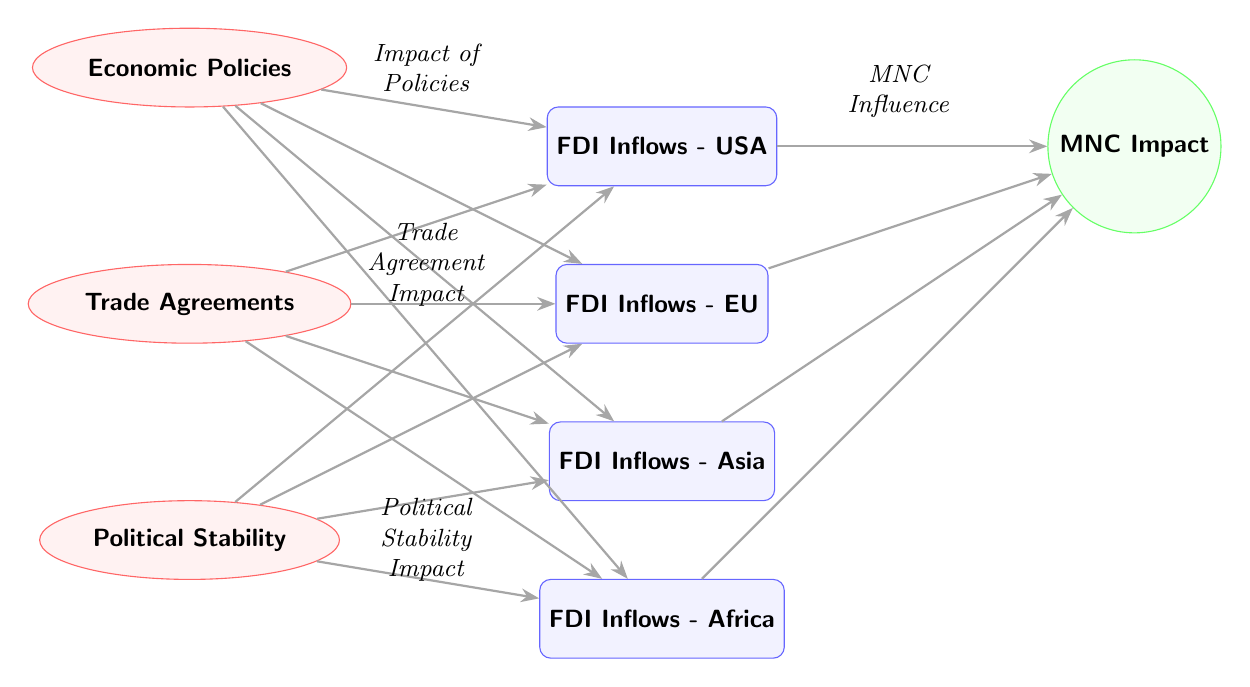What are the regions represented in the FDI inflows nodes? The diagram shows four FDI inflow nodes labeled as USA, EU, Asia, and Africa. These represent the different regions where FDI inflows are analyzed.
Answer: USA, EU, Asia, Africa How many factors influence FDI inflows according to the diagram? There are three factors depicted that influence FDI inflows: Economic Policies, Trade Agreements, and Political Stability. This can be determined by counting the factor nodes connected to the FDI inflow nodes.
Answer: 3 Which factor directly impacts the FDI inflows in Africa? Political Stability is the factor that directly impacts the FDI inflows in Africa as indicated by the arrow pointing from the Stability node to the Africa FDI inflow node.
Answer: Political Stability What is the relationship between MNC Impact and the FDI inflows? The diagram illustrates that MNC Impact is influenced by all four regions' FDI inflows (USA, EU, Asia, Africa) as indicated by the arrows pointing from each regional inflow node to the MNC Impact node.
Answer: MNC Impact is influenced by FDI inflows Which region has the most factors influencing its FDI inflows? All regions (USA, EU, Asia, Africa) have the same number of influencing factors (three: Economic Policies, Trade Agreements, Political Stability), hence no single region stands out in terms of having more influencing factors.
Answer: Equal influence across regions 